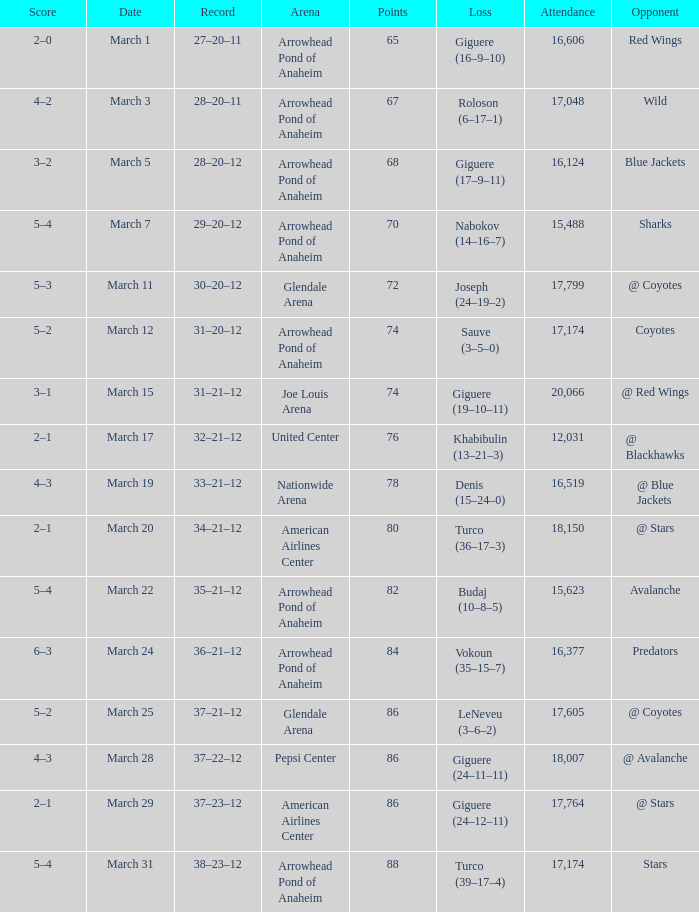What is the Score of the game on March 19? 4–3. Give me the full table as a dictionary. {'header': ['Score', 'Date', 'Record', 'Arena', 'Points', 'Loss', 'Attendance', 'Opponent'], 'rows': [['2–0', 'March 1', '27–20–11', 'Arrowhead Pond of Anaheim', '65', 'Giguere (16–9–10)', '16,606', 'Red Wings'], ['4–2', 'March 3', '28–20–11', 'Arrowhead Pond of Anaheim', '67', 'Roloson (6–17–1)', '17,048', 'Wild'], ['3–2', 'March 5', '28–20–12', 'Arrowhead Pond of Anaheim', '68', 'Giguere (17–9–11)', '16,124', 'Blue Jackets'], ['5–4', 'March 7', '29–20–12', 'Arrowhead Pond of Anaheim', '70', 'Nabokov (14–16–7)', '15,488', 'Sharks'], ['5–3', 'March 11', '30–20–12', 'Glendale Arena', '72', 'Joseph (24–19–2)', '17,799', '@ Coyotes'], ['5–2', 'March 12', '31–20–12', 'Arrowhead Pond of Anaheim', '74', 'Sauve (3–5–0)', '17,174', 'Coyotes'], ['3–1', 'March 15', '31–21–12', 'Joe Louis Arena', '74', 'Giguere (19–10–11)', '20,066', '@ Red Wings'], ['2–1', 'March 17', '32–21–12', 'United Center', '76', 'Khabibulin (13–21–3)', '12,031', '@ Blackhawks'], ['4–3', 'March 19', '33–21–12', 'Nationwide Arena', '78', 'Denis (15–24–0)', '16,519', '@ Blue Jackets'], ['2–1', 'March 20', '34–21–12', 'American Airlines Center', '80', 'Turco (36–17–3)', '18,150', '@ Stars'], ['5–4', 'March 22', '35–21–12', 'Arrowhead Pond of Anaheim', '82', 'Budaj (10–8–5)', '15,623', 'Avalanche'], ['6–3', 'March 24', '36–21–12', 'Arrowhead Pond of Anaheim', '84', 'Vokoun (35–15–7)', '16,377', 'Predators'], ['5–2', 'March 25', '37–21–12', 'Glendale Arena', '86', 'LeNeveu (3–6–2)', '17,605', '@ Coyotes'], ['4–3', 'March 28', '37–22–12', 'Pepsi Center', '86', 'Giguere (24–11–11)', '18,007', '@ Avalanche'], ['2–1', 'March 29', '37–23–12', 'American Airlines Center', '86', 'Giguere (24–12–11)', '17,764', '@ Stars'], ['5–4', 'March 31', '38–23–12', 'Arrowhead Pond of Anaheim', '88', 'Turco (39–17–4)', '17,174', 'Stars']]} 